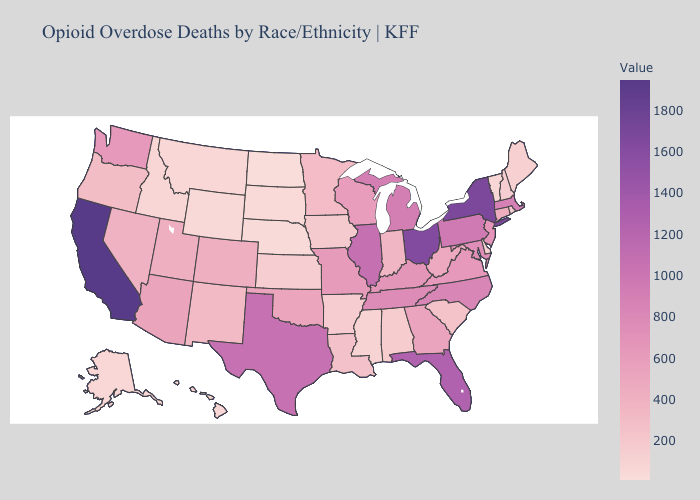Which states hav the highest value in the Northeast?
Keep it brief. New York. Among the states that border Connecticut , which have the lowest value?
Keep it brief. Rhode Island. Which states hav the highest value in the MidWest?
Write a very short answer. Ohio. Does California have the highest value in the USA?
Short answer required. Yes. Among the states that border Arizona , does New Mexico have the highest value?
Quick response, please. No. 